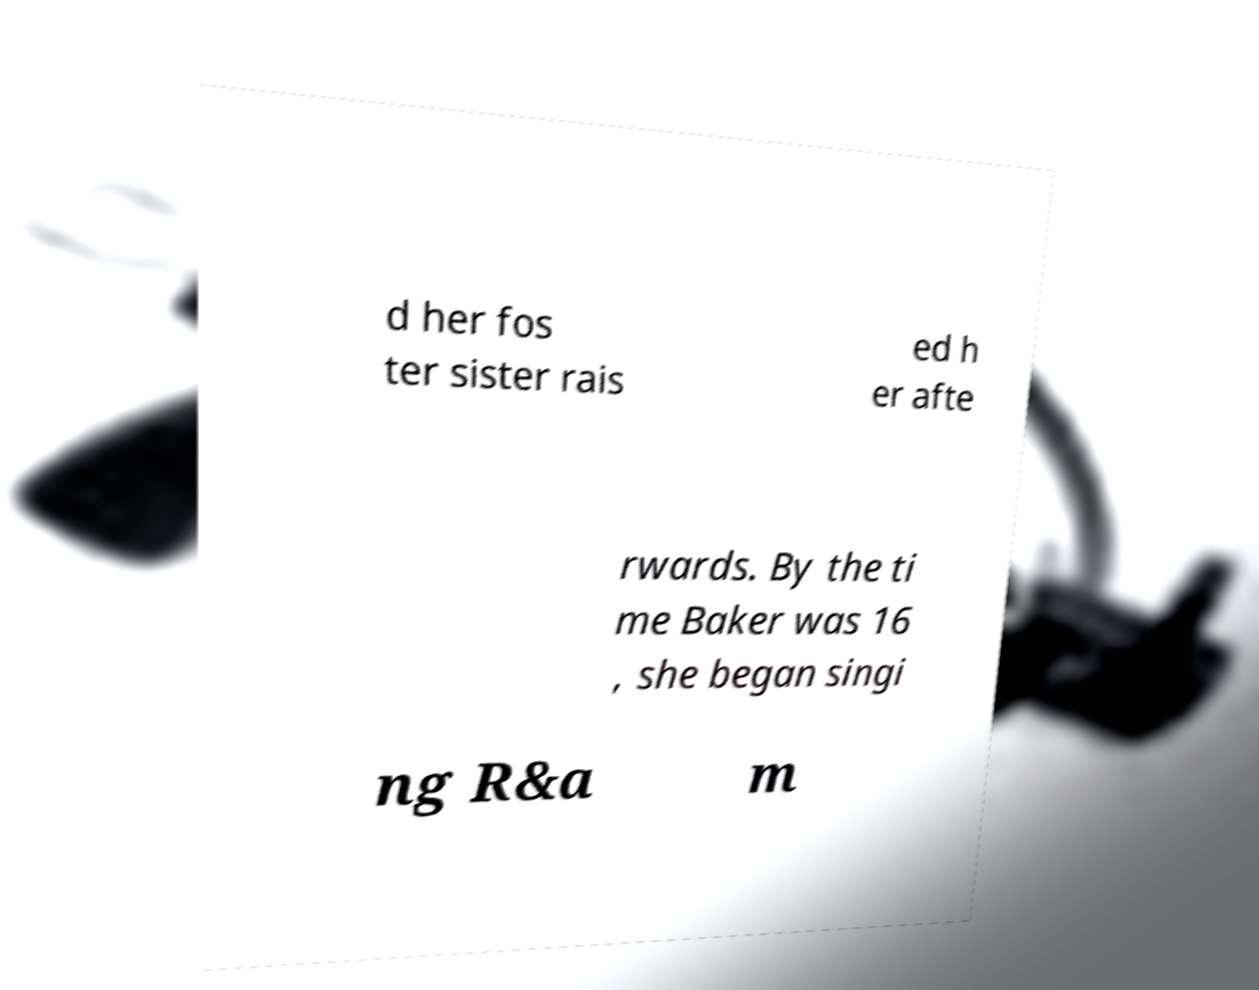Could you extract and type out the text from this image? d her fos ter sister rais ed h er afte rwards. By the ti me Baker was 16 , she began singi ng R&a m 